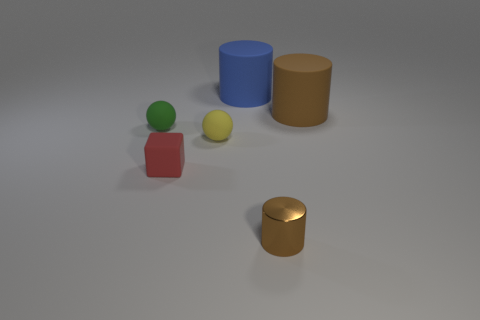Are there any other things that have the same material as the small brown cylinder?
Your answer should be very brief. No. There is a cylinder that is the same color as the metal object; what material is it?
Provide a succinct answer. Rubber. Does the metallic thing have the same color as the matte cube?
Give a very brief answer. No. How many green things are either matte objects or tiny cylinders?
Provide a short and direct response. 1. Are there any big yellow metallic objects?
Keep it short and to the point. No. There is a big cylinder that is behind the big cylinder on the right side of the tiny brown cylinder; is there a blue rubber thing behind it?
Keep it short and to the point. No. Is the shape of the tiny yellow rubber thing the same as the green rubber thing behind the metallic cylinder?
Make the answer very short. Yes. The ball to the right of the cube in front of the small rubber ball to the left of the yellow ball is what color?
Offer a terse response. Yellow. How many objects are either large rubber cylinders that are right of the large blue rubber cylinder or things that are on the left side of the metal thing?
Your response must be concise. 5. What number of other things are there of the same color as the metal thing?
Offer a very short reply. 1. 